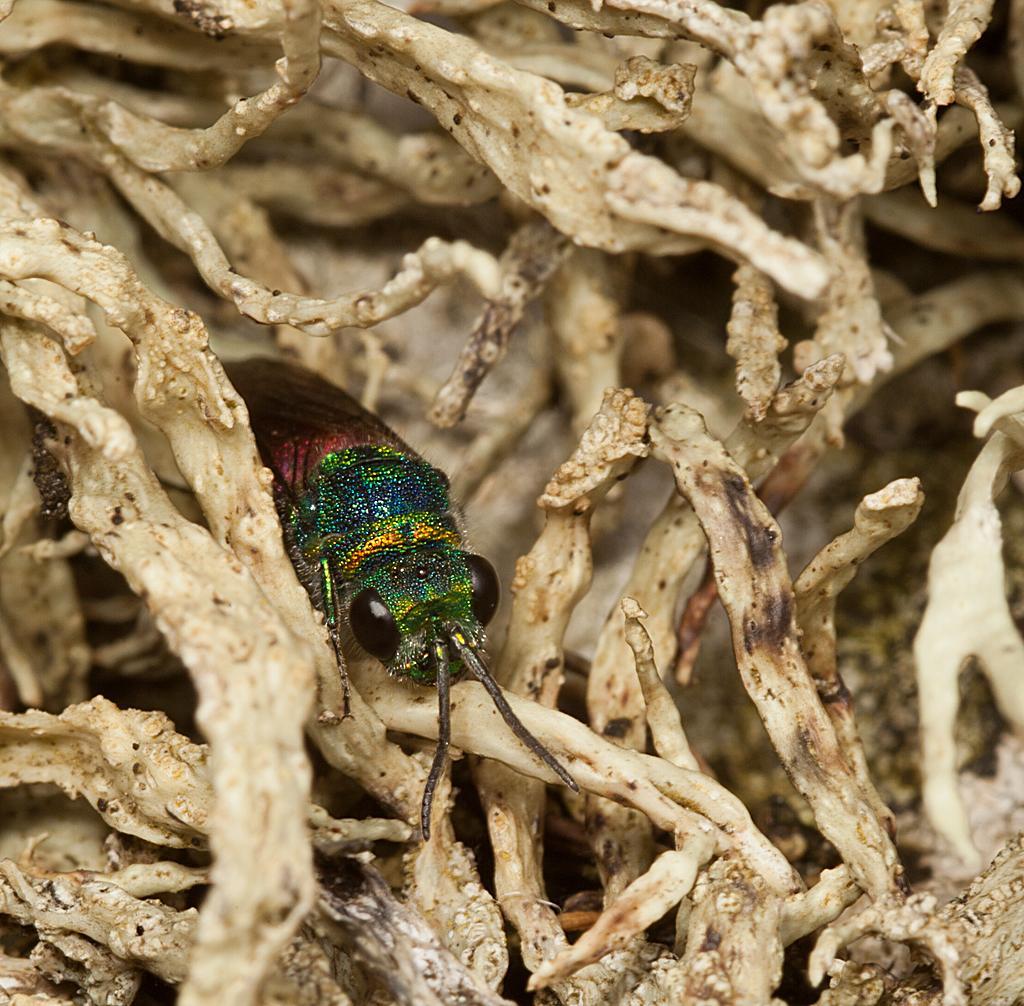Can you describe this image briefly? In the center of the image we can see an insect is there. In the background of the image we can see a dry leaves are there. 